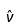Convert formula to latex. <formula><loc_0><loc_0><loc_500><loc_500>\hat { \nu }</formula> 